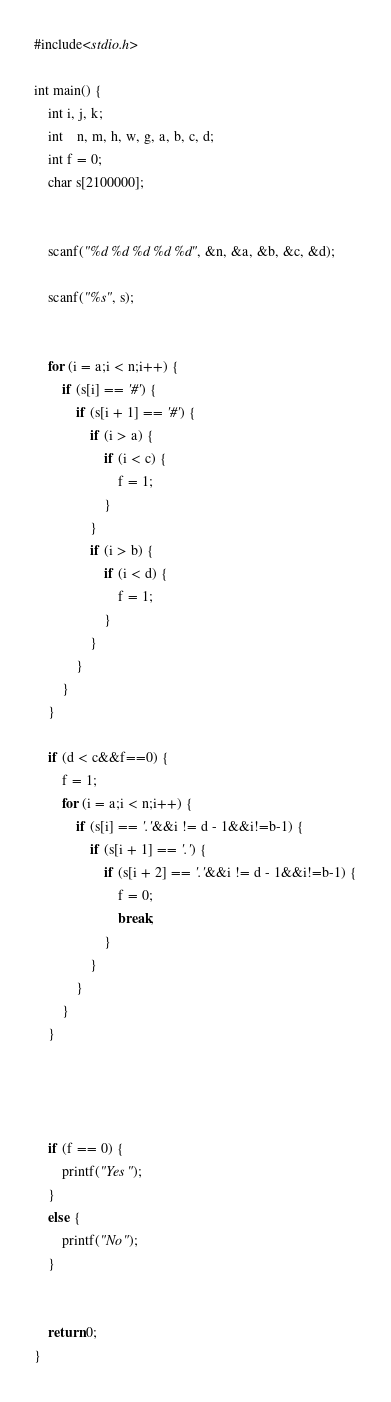Convert code to text. <code><loc_0><loc_0><loc_500><loc_500><_C_>#include<stdio.h>

int main() {
	int i, j, k;
	int	n, m, h, w, g, a, b, c, d;
	int f = 0;
	char s[2100000];


	scanf("%d %d %d %d %d", &n, &a, &b, &c, &d);

	scanf("%s", s);


	for (i = a;i < n;i++) {
		if (s[i] == '#') {
			if (s[i + 1] == '#') {
				if (i > a) {
					if (i < c) {
						f = 1;
					}
				}
				if (i > b) {
					if (i < d) {
						f = 1;
					}
				}
			}
		}
	}

	if (d < c&&f==0) {
		f = 1;
		for (i = a;i < n;i++) {
			if (s[i] == '.'&&i != d - 1&&i!=b-1) {
				if (s[i + 1] == '.') {
					if (s[i + 2] == '.'&&i != d - 1&&i!=b-1) {
						f = 0;
						break;
					}
				}
			}
		}
	}




	if (f == 0) {
		printf("Yes");
	}
	else {
		printf("No");
	}


	return 0;
}</code> 